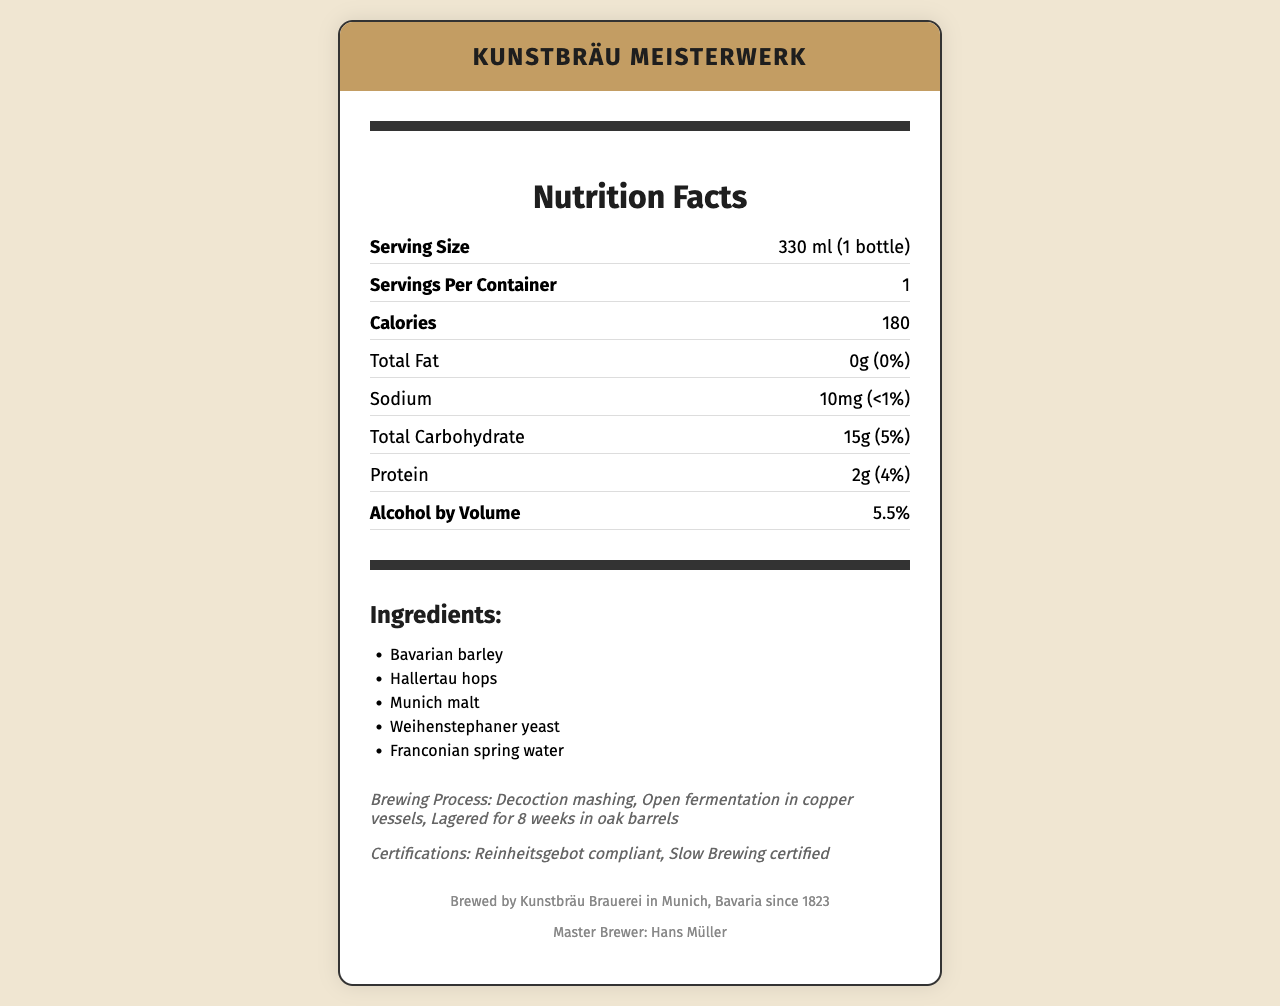who is the Master Brewer of Kunstbräu Brauerei? The document mentions that the Master Brewer is Hans Müller.
Answer: Hans Müller what is the serving size of Kunstbräu Meisterwerk artisanal German beer? The serving size is specified as 330 ml, equivalent to 1 bottle.
Answer: 330 ml (1 bottle) how many calories are in one serving of this beer? According to the Nutrition Facts, one serving contains 180 calories.
Answer: 180 what ingredients are used in Kunstbräu Meisterwerk? The document lists these ingredients under the ingredients section.
Answer: Bavarian barley, Hallertau hops, Munich malt, Weihenstephaner yeast, Franconian spring water how much protein is in the beer per serving? The protein content per serving is 2 grams, as stated in the Nutrition Facts.
Answer: 2g what type of fermentation is used in the brewing process? The fermentation technique mentioned is open fermentation in copper vessels.
Answer: Open fermentation in copper vessels what is the alcohol by volume (ABV) percentage of Kunstbräu Meisterwerk? The ABV is listed as 5.5% in the document.
Answer: 5.5% what are the daily value percentages for total fat and sodium in this beer? The daily value for total fat is 0% and for sodium is less than 1%.
Answer: 0% and <1% which certifications does Kunstbräu Meisterwerk hold? The document lists these certifications in the additional info section.
Answer: Reinheitsgebot compliant, Slow Brewing certified where is Kunstbräu Brauerei located? The brewery is located in Munich, Bavaria, as per the brewery info.
Answer: Munich, Bavaria which of the following is NOT listed as an ingredient? A. Munich malt B. Franconian spring water C. Rye malt The listed ingredients are Bavarian barley, Hallertau hops, Munich malt, Weihenstephaner yeast, and Franconian spring water. Rye malt is not listed.
Answer: C. Rye malt how is the mashing technique described for this beer? A. Single infusion B. Decoction mashing C. Continuous mashing D. Batch sparging The mashing technique is specified as decoction mashing.
Answer: B. Decoction mashing does the serving size include more than one serving per container? The document specifies that there is 1 serving per container.
Answer: No summarize the key details of Kunstbräu Meisterwerk artisanal German beer. This detailed summary includes key aspects such as nutritional values, ingredients, brewing process, and certifications.
Answer: Kunstbräu Meisterwerk is an artisanal German beer brewed in Munich, Bavaria. It has a serving size of 330 ml per container with 180 calories per serving. The beer contains 0g of total fat, 10mg of sodium, 15g of total carbohydrates, 2g of protein, and has an alcohol by volume (ABV) of 5.5%. The ingredients include Bavarian barley, Hallertau hops, Munich malt, Weihenstephaner yeast, and Franconian spring water. It is brewed using decoction mashing, open fermentation in copper vessels, and aged for 8 weeks in oak barrels. The beer is Reinheitsgebot compliant and Slow Brewing certified. when was Kunstbräu Brauerei established? The document states that the brewery was established in 1823.
Answer: 1823 is the packaging of Kunstbräu Meisterwerk eco-friendly? The packaging is described as 100% recyclable glass bottle, indicating it is eco-friendly.
Answer: Yes what does the color palette of the label design reflect? While the document mentions a color palette inspired by Munich's skyline at sunset, it does not provide visual details to confirm what the color palette specifically reflects.
Answer: Cannot be determined 